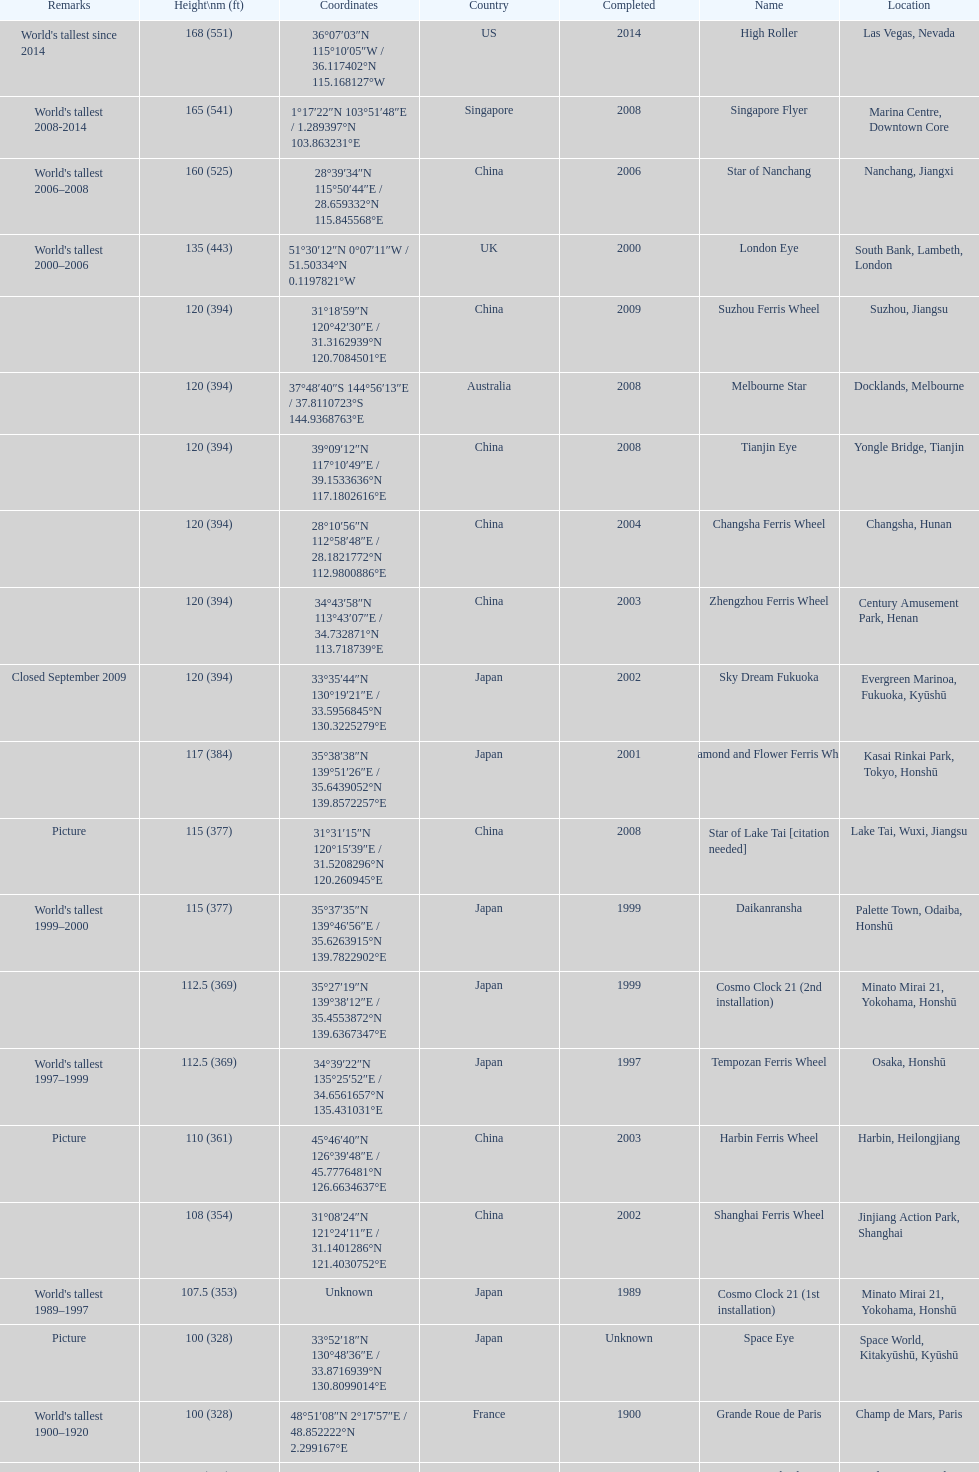Where was the original tallest roller coster built? Chicago. 